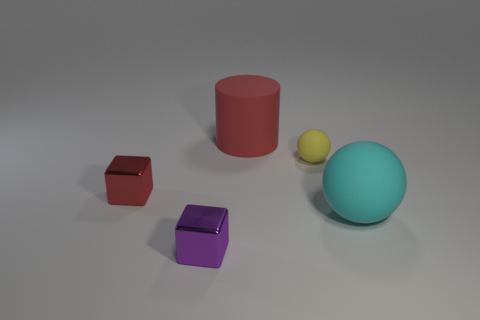There is a red thing that is in front of the red cylinder; is it the same size as the purple block?
Make the answer very short. Yes. Are there fewer small rubber things that are right of the small matte sphere than big green metal balls?
Offer a terse response. No. Is there any other thing that has the same size as the cyan rubber object?
Offer a very short reply. Yes. There is a matte ball that is right of the tiny thing to the right of the large red rubber object; what is its size?
Keep it short and to the point. Large. Is there any other thing that is the same shape as the cyan rubber thing?
Provide a short and direct response. Yes. Are there fewer large red things than large matte things?
Your answer should be very brief. Yes. What is the object that is right of the red rubber cylinder and on the left side of the cyan rubber ball made of?
Your answer should be very brief. Rubber. Is there a small yellow matte thing that is left of the large rubber object that is behind the large matte ball?
Offer a very short reply. No. What number of things are purple cubes or tiny objects?
Provide a short and direct response. 3. There is a small object that is both behind the big sphere and left of the yellow thing; what is its shape?
Your answer should be compact. Cube. 